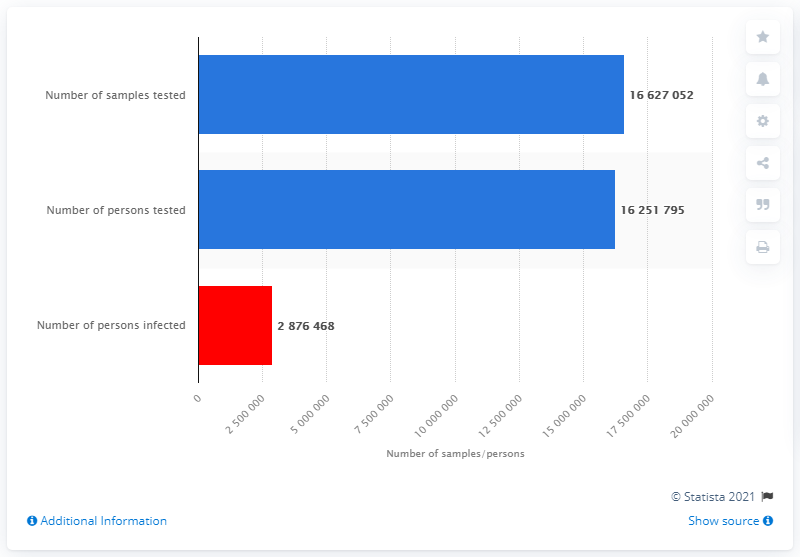Outline some significant characteristics in this image. The number of COVID-19 positive samples is 2876468... As of June 13th, 2021, a total of 16,627,052 samples were tested for COVID-19 coronavirus in Poland. 